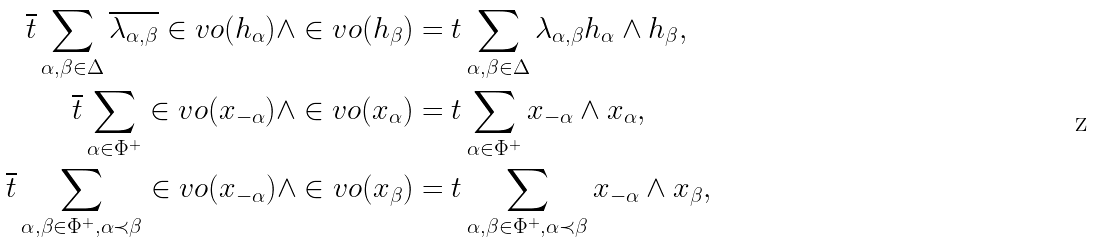<formula> <loc_0><loc_0><loc_500><loc_500>\overline { t } \sum _ { \alpha , \beta \in \Delta } \overline { \lambda _ { \alpha , \beta } } \in v o ( h _ { \alpha } ) \wedge \in v o ( h _ { \beta } ) & = t \sum _ { \alpha , \beta \in \Delta } \lambda _ { \alpha , \beta } h _ { \alpha } \wedge h _ { \beta } , \\ \overline { t } \sum _ { \alpha \in \Phi ^ { + } } \in v o ( x _ { - \alpha } ) \wedge \in v o ( x _ { \alpha } ) & = t \sum _ { \alpha \in \Phi ^ { + } } x _ { - \alpha } \wedge x _ { \alpha } , \\ \overline { t } \sum _ { \alpha , \beta \in \Phi ^ { + } , \alpha \prec \beta } \in v o ( x _ { - \alpha } ) \wedge \in v o ( x _ { \beta } ) & = t \sum _ { \alpha , \beta \in \Phi ^ { + } , \alpha \prec \beta } x _ { - \alpha } \wedge x _ { \beta } ,</formula> 